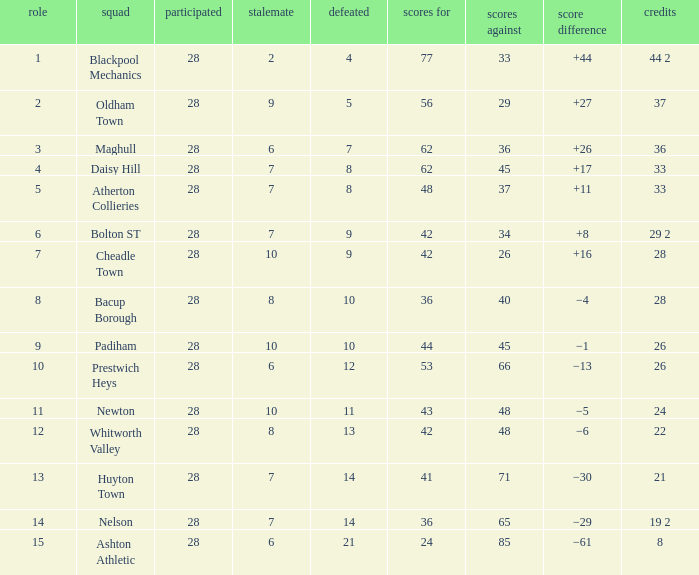For entries with lost larger than 21 and goals for smaller than 36, what is the average drawn? None. 